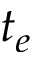Convert formula to latex. <formula><loc_0><loc_0><loc_500><loc_500>t _ { e }</formula> 